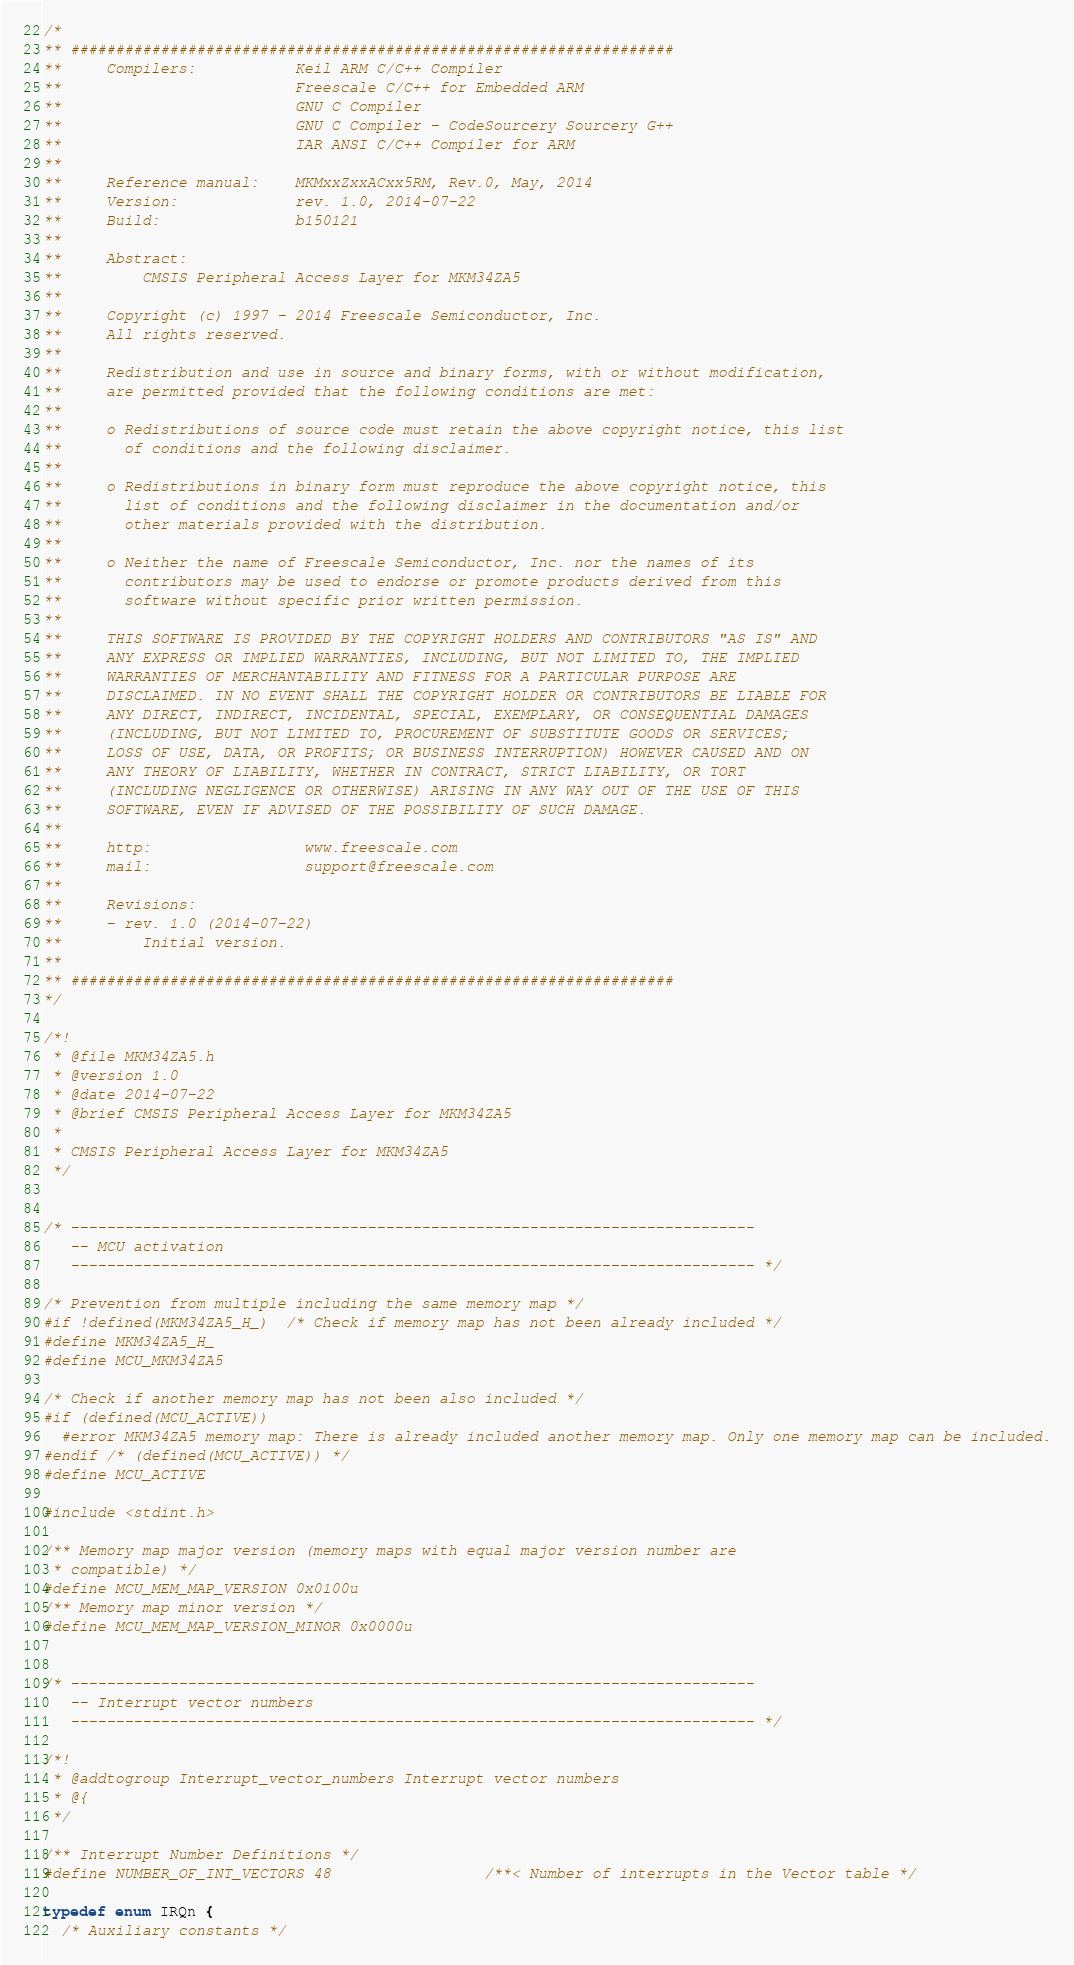<code> <loc_0><loc_0><loc_500><loc_500><_C_>/*
** ###################################################################
**     Compilers:           Keil ARM C/C++ Compiler
**                          Freescale C/C++ for Embedded ARM
**                          GNU C Compiler
**                          GNU C Compiler - CodeSourcery Sourcery G++
**                          IAR ANSI C/C++ Compiler for ARM
**
**     Reference manual:    MKMxxZxxACxx5RM, Rev.0, May, 2014
**     Version:             rev. 1.0, 2014-07-22
**     Build:               b150121
**
**     Abstract:
**         CMSIS Peripheral Access Layer for MKM34ZA5
**
**     Copyright (c) 1997 - 2014 Freescale Semiconductor, Inc.
**     All rights reserved.
**
**     Redistribution and use in source and binary forms, with or without modification,
**     are permitted provided that the following conditions are met:
**
**     o Redistributions of source code must retain the above copyright notice, this list
**       of conditions and the following disclaimer.
**
**     o Redistributions in binary form must reproduce the above copyright notice, this
**       list of conditions and the following disclaimer in the documentation and/or
**       other materials provided with the distribution.
**
**     o Neither the name of Freescale Semiconductor, Inc. nor the names of its
**       contributors may be used to endorse or promote products derived from this
**       software without specific prior written permission.
**
**     THIS SOFTWARE IS PROVIDED BY THE COPYRIGHT HOLDERS AND CONTRIBUTORS "AS IS" AND
**     ANY EXPRESS OR IMPLIED WARRANTIES, INCLUDING, BUT NOT LIMITED TO, THE IMPLIED
**     WARRANTIES OF MERCHANTABILITY AND FITNESS FOR A PARTICULAR PURPOSE ARE
**     DISCLAIMED. IN NO EVENT SHALL THE COPYRIGHT HOLDER OR CONTRIBUTORS BE LIABLE FOR
**     ANY DIRECT, INDIRECT, INCIDENTAL, SPECIAL, EXEMPLARY, OR CONSEQUENTIAL DAMAGES
**     (INCLUDING, BUT NOT LIMITED TO, PROCUREMENT OF SUBSTITUTE GOODS OR SERVICES;
**     LOSS OF USE, DATA, OR PROFITS; OR BUSINESS INTERRUPTION) HOWEVER CAUSED AND ON
**     ANY THEORY OF LIABILITY, WHETHER IN CONTRACT, STRICT LIABILITY, OR TORT
**     (INCLUDING NEGLIGENCE OR OTHERWISE) ARISING IN ANY WAY OUT OF THE USE OF THIS
**     SOFTWARE, EVEN IF ADVISED OF THE POSSIBILITY OF SUCH DAMAGE.
**
**     http:                 www.freescale.com
**     mail:                 support@freescale.com
**
**     Revisions:
**     - rev. 1.0 (2014-07-22)
**         Initial version.
**
** ###################################################################
*/

/*!
 * @file MKM34ZA5.h
 * @version 1.0
 * @date 2014-07-22
 * @brief CMSIS Peripheral Access Layer for MKM34ZA5
 *
 * CMSIS Peripheral Access Layer for MKM34ZA5
 */


/* ----------------------------------------------------------------------------
   -- MCU activation
   ---------------------------------------------------------------------------- */

/* Prevention from multiple including the same memory map */
#if !defined(MKM34ZA5_H_)  /* Check if memory map has not been already included */
#define MKM34ZA5_H_
#define MCU_MKM34ZA5

/* Check if another memory map has not been also included */
#if (defined(MCU_ACTIVE))
  #error MKM34ZA5 memory map: There is already included another memory map. Only one memory map can be included.
#endif /* (defined(MCU_ACTIVE)) */
#define MCU_ACTIVE

#include <stdint.h>

/** Memory map major version (memory maps with equal major version number are
 * compatible) */
#define MCU_MEM_MAP_VERSION 0x0100u
/** Memory map minor version */
#define MCU_MEM_MAP_VERSION_MINOR 0x0000u


/* ----------------------------------------------------------------------------
   -- Interrupt vector numbers
   ---------------------------------------------------------------------------- */

/*!
 * @addtogroup Interrupt_vector_numbers Interrupt vector numbers
 * @{
 */

/** Interrupt Number Definitions */
#define NUMBER_OF_INT_VECTORS 48                 /**< Number of interrupts in the Vector table */

typedef enum IRQn {
  /* Auxiliary constants */</code> 